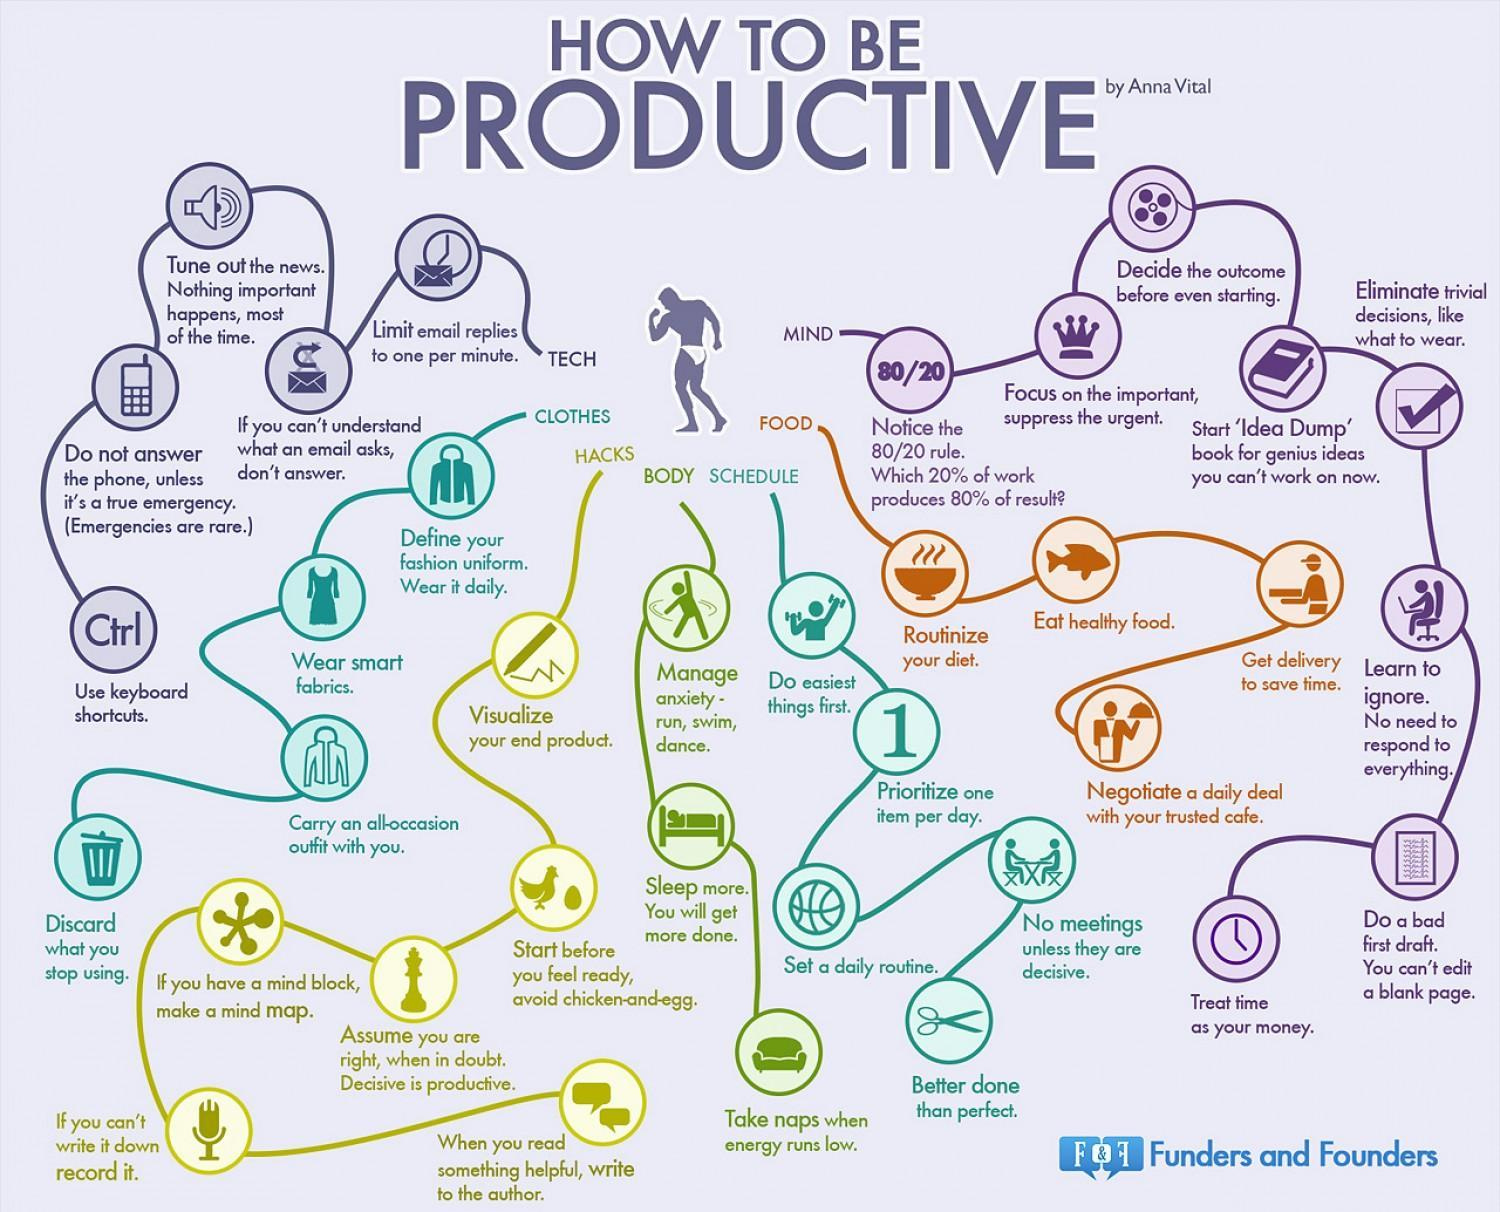What is the third physical activity mentioned that helps to manage anxiety?
Answer the question with a short phrase. dance How many tips are mentioned under the subheading FOOD? 4 Which item should you discard if you stop using? Clothes What item can get delivered to save time? Food 